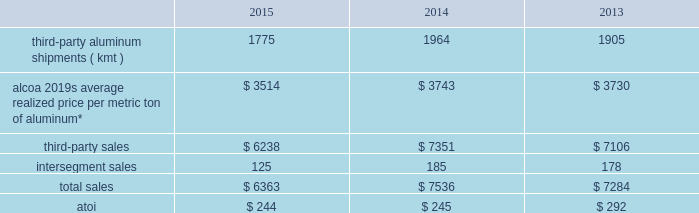Purchased scrap metal from third-parties ) that were either divested or permanently closed in december 2014 ( see global rolled products below ) .
Intersegment sales for this segment improved 12% ( 12 % ) in 2014 compared with 2013 , principally due to an increase in average realized price , driven by higher regional premiums , and higher demand from the midstream and downstream businesses .
Atoi for the primary metals segment decreased $ 439 in 2015 compared with 2014 , primarily caused by both the previously mentioned lower average realized aluminum price and lower energy sales , higher energy costs ( mostly in spain as the 2014 interruptibility rights were more favorable than the 2015 structure ) , and an unfavorable impact related to the curtailment of the s e3o lu eds smelter .
These negative impacts were somewhat offset by net favorable foreign currency movements due to a stronger u.s .
Dollar against most major currencies , net productivity improvements , the absence of a write-off of inventory related to the permanent closure of the portovesme , point henry , and massena east smelters ( $ 44 ) , and a lower equity loss related to the joint venture in saudi arabia , including the absence of restart costs for one of the potlines that was previously shut down due to a period of instability .
Atoi for this segment climbed $ 614 in 2014 compared with 2013 , principally related to a higher average realized aluminum price ; the previously mentioned energy sales in brazil ; net productivity improvements ; net favorable foreign currency movements due to a stronger u.s .
Dollar against all major currencies ; lower costs for carbon and alumina ; and the absence of costs related to a planned maintenance outage in 2013 at a power plant in australia .
These positive impacts were slightly offset by an unfavorable impact associated with the 2013 and 2014 capacity reductions described above , including a write-off of inventory related to the permanent closure of the portovesme , point henry , and massena east smelters ( $ 44 ) , and higher energy costs ( particularly in spain ) , labor , and maintenance .
In 2016 , aluminum production will be approximately 450 kmt lower and third-party sales will reflect the absence of approximately $ 400 both as a result of the 2015 curtailment and closure actions .
Also , energy sales in brazil will be negatively impacted by a decline in energy prices , while net productivity improvements are anticipated .
Global rolled products .
* generally , average realized price per metric ton of aluminum includes two elements : a ) the price of metal ( the underlying base metal component plus a regional premium 2013 see the footnote to the table in primary metals above for a description of these two components ) , and b ) the conversion price , which represents the incremental price over the metal price component that is associated with converting primary aluminum into sheet and plate .
In this circumstance , the metal price component is a pass- through to this segment 2019s customers with limited exception ( e.g. , fixed-priced contracts , certain regional premiums ) .
This segment represents alcoa 2019s midstream operations and produces aluminum sheet and plate for a variety of end markets .
Approximately one-half of the third-party shipments in this segment consist of sheet sold directly to customers in the packaging end market for the production of aluminum cans ( beverage , food , and pet food ) .
Seasonal increases in can sheet sales are generally experienced in the second and third quarters of the year .
This segment also includes sheet and plate sold directly to customers and through distributors related to the aerospace , automotive , commercial transportation , building and construction , and industrial products ( mainly used in the production of machinery and equipment and consumer durables ) end markets .
A small portion of this segment also produces aseptic foil for the packaging end market .
While the customer base for flat-rolled products is large , a significant amount of sales of sheet and plate is to a relatively small number of customers .
In this circumstance , the sales and costs and expenses of this segment are transacted in the local currency of the respective operations , which are mostly the u.s .
Dollar , the euro , the russian ruble , the brazilian real , and the british pound. .
Considering the year 2014 , what is the percentage of intersegment sales concerning total sales? 
Rationale: it is the total of dollars brought by the intersegment sales divided by the total of dollars associated with total sales .
Computations: (185 / 7536)
Answer: 0.02455. 